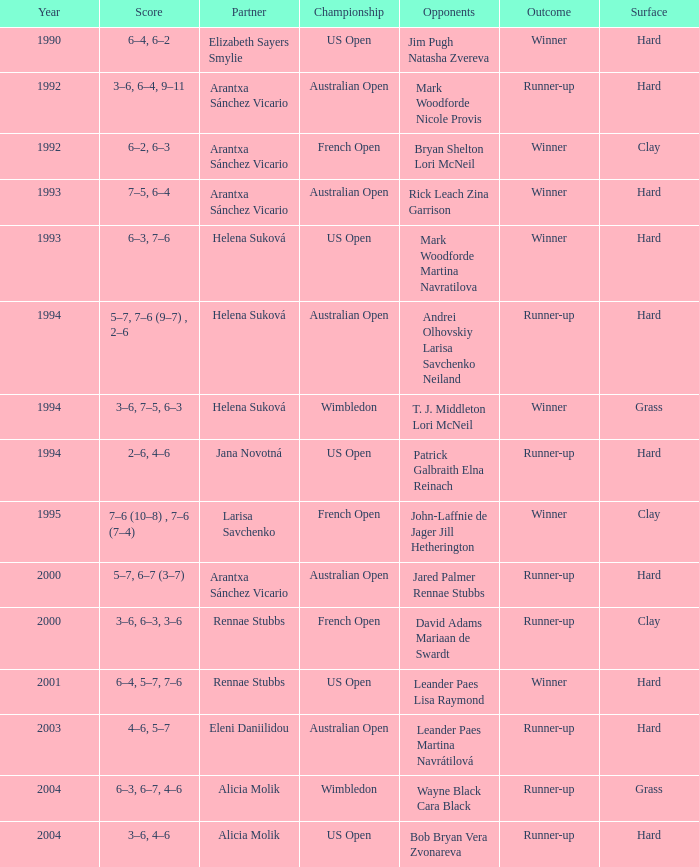Who was the Partner that was a winner, a Year smaller than 1993, and a Score of 6–4, 6–2? Elizabeth Sayers Smylie. 